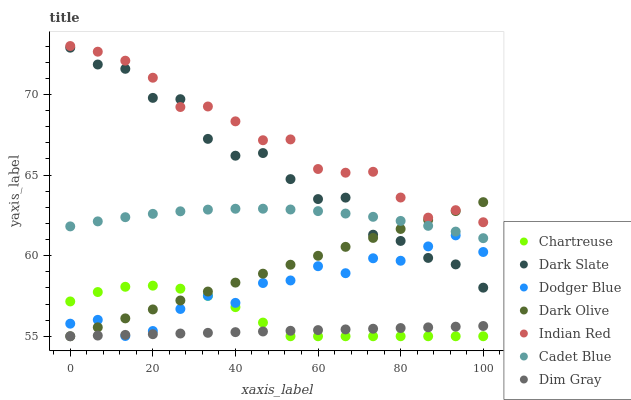Does Dim Gray have the minimum area under the curve?
Answer yes or no. Yes. Does Indian Red have the maximum area under the curve?
Answer yes or no. Yes. Does Dark Olive have the minimum area under the curve?
Answer yes or no. No. Does Dark Olive have the maximum area under the curve?
Answer yes or no. No. Is Dim Gray the smoothest?
Answer yes or no. Yes. Is Dark Slate the roughest?
Answer yes or no. Yes. Is Dark Olive the smoothest?
Answer yes or no. No. Is Dark Olive the roughest?
Answer yes or no. No. Does Dark Olive have the lowest value?
Answer yes or no. Yes. Does Dark Slate have the lowest value?
Answer yes or no. No. Does Indian Red have the highest value?
Answer yes or no. Yes. Does Dark Olive have the highest value?
Answer yes or no. No. Is Chartreuse less than Dark Slate?
Answer yes or no. Yes. Is Cadet Blue greater than Chartreuse?
Answer yes or no. Yes. Does Dark Olive intersect Indian Red?
Answer yes or no. Yes. Is Dark Olive less than Indian Red?
Answer yes or no. No. Is Dark Olive greater than Indian Red?
Answer yes or no. No. Does Chartreuse intersect Dark Slate?
Answer yes or no. No. 